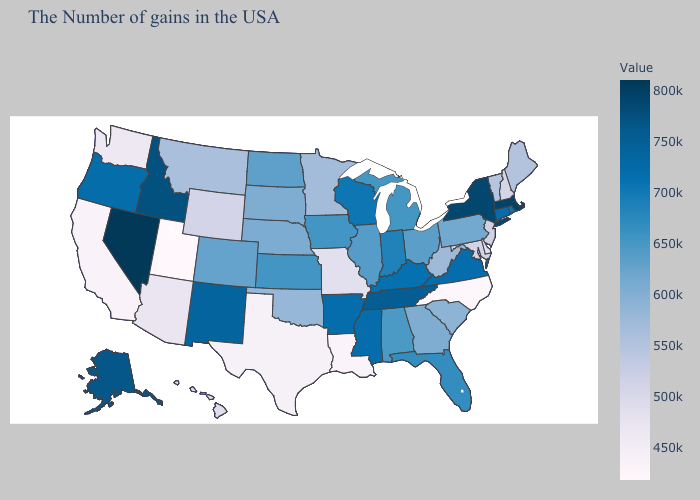Does Louisiana have the lowest value in the USA?
Give a very brief answer. No. Does Mississippi have a higher value than Illinois?
Keep it brief. Yes. Among the states that border North Carolina , does Georgia have the highest value?
Quick response, please. No. 